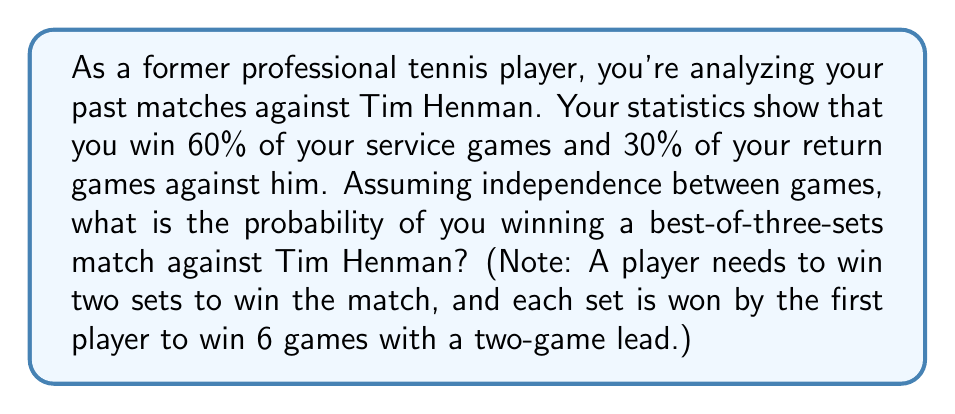Show me your answer to this math problem. Let's approach this step-by-step:

1) First, we need to calculate the probability of winning a single set. To win a set, you need to win more games than your opponent out of 12 games (assuming no tie-break).

2) The probability of winning your service game is 0.6, and the probability of winning Henman's service game is 0.3. Assuming you serve first (it doesn't affect the overall probability), the probability of winning each game in the set is:

   $$(0.6, 0.3, 0.6, 0.3, 0.6, 0.3, 0.6, 0.3, 0.6, 0.3, 0.6, 0.3)$$

3) To win the set, you need to win at least 7 out of these 12 games. This follows a binomial distribution with $n=12$ and $p=0.45$ (average of 0.6 and 0.3).

4) The probability of winning the set is:

   $$P(\text{win set}) = \sum_{k=7}^{12} \binom{12}{k} (0.45)^k (0.55)^{12-k} \approx 0.6179$$

5) Now, to win the match, you need to win 2 out of 3 sets. This again follows a binomial distribution with $n=3$ and $p=0.6179$.

6) The probability of winning the match is:

   $$P(\text{win match}) = \binom{3}{2} (0.6179)^2 (1-0.6179) + \binom{3}{3} (0.6179)^3$$

   $$= 3 \cdot (0.6179)^2 \cdot 0.3821 + (0.6179)^3$$

   $$\approx 0.7072$$
Answer: The probability of winning a best-of-three-sets match against Tim Henman, given the specified statistics, is approximately 0.7072 or 70.72%. 